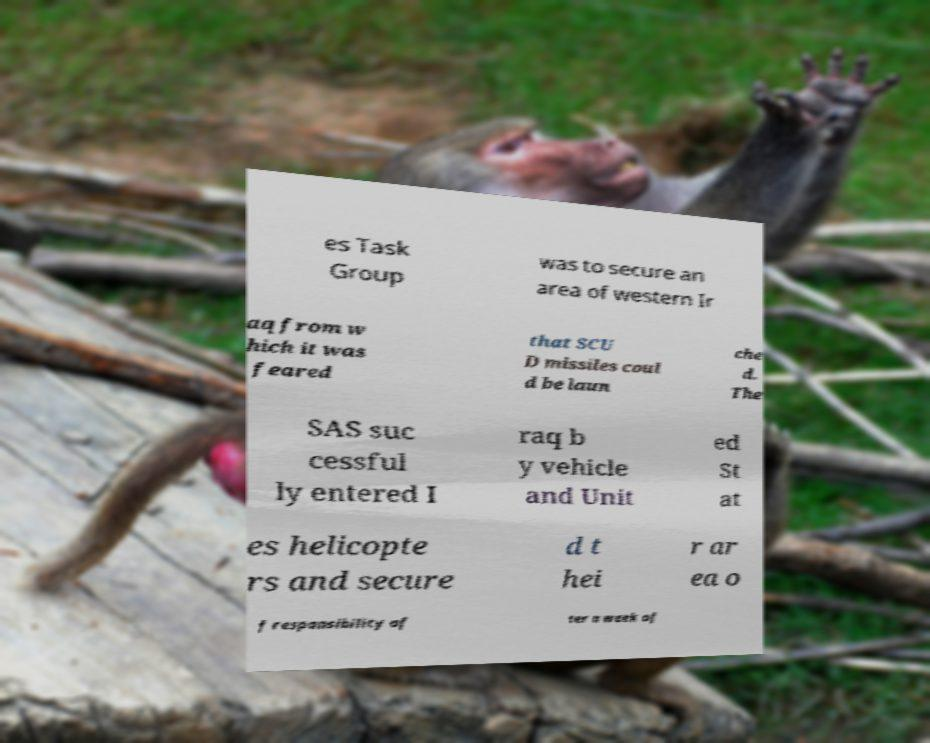Please identify and transcribe the text found in this image. es Task Group was to secure an area of western Ir aq from w hich it was feared that SCU D missiles coul d be laun che d. The SAS suc cessful ly entered I raq b y vehicle and Unit ed St at es helicopte rs and secure d t hei r ar ea o f responsibility af ter a week of 